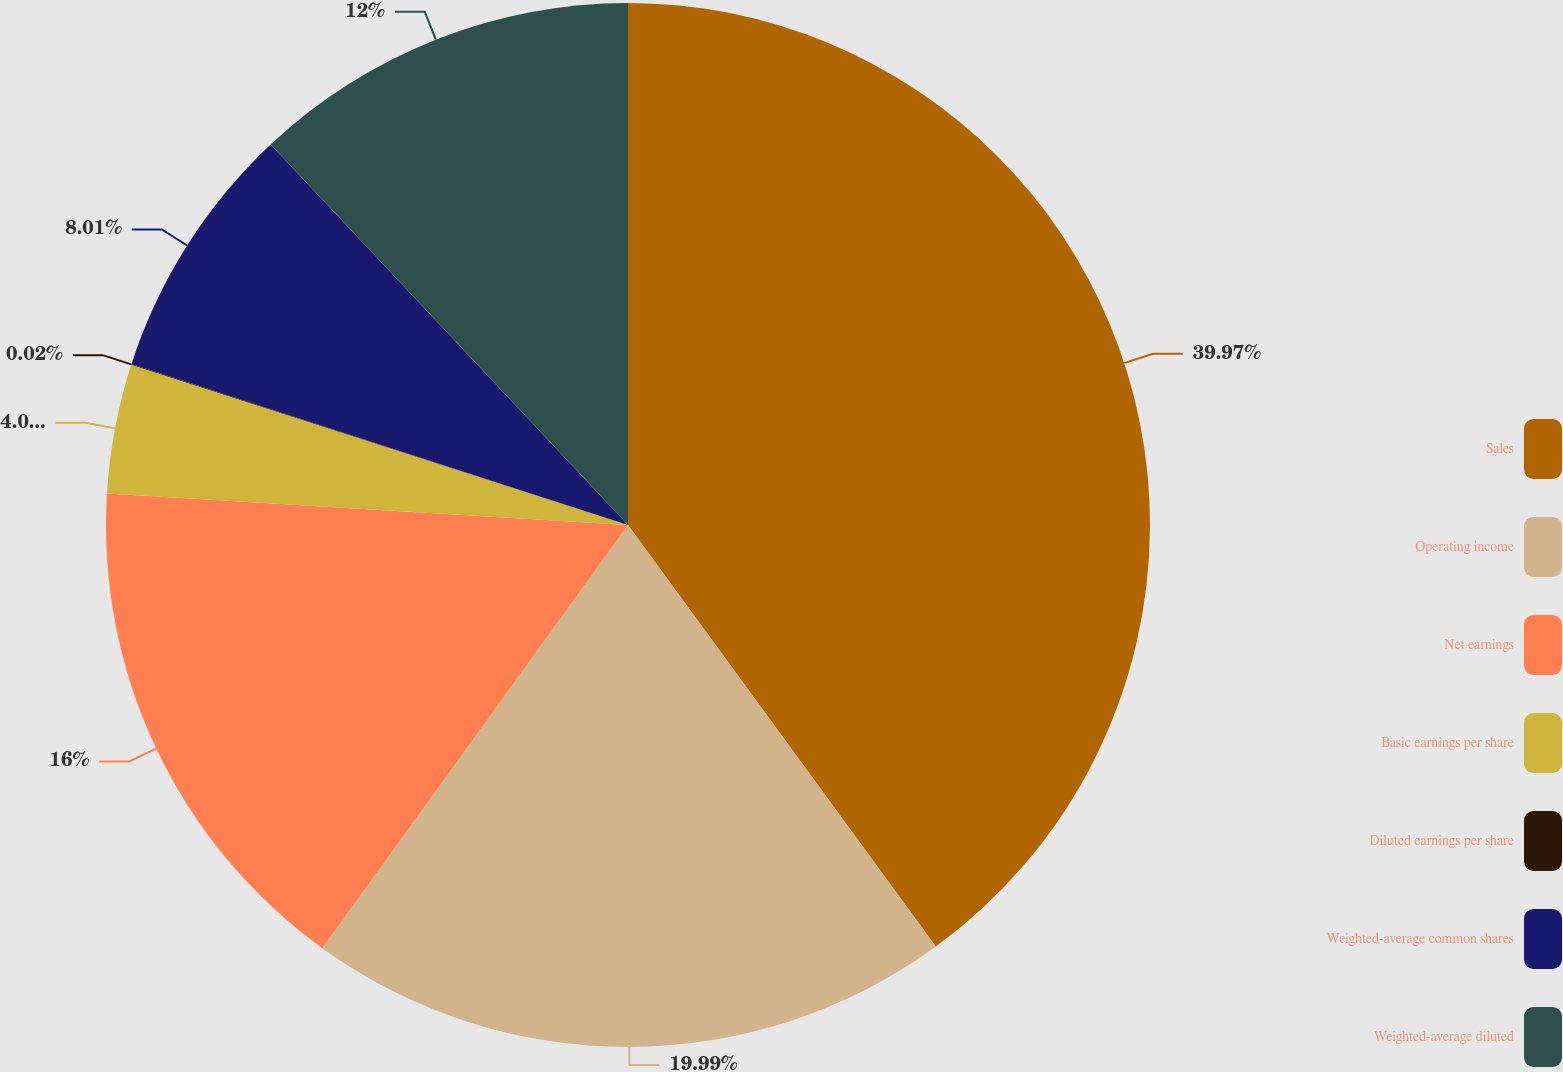Convert chart. <chart><loc_0><loc_0><loc_500><loc_500><pie_chart><fcel>Sales<fcel>Operating income<fcel>Net earnings<fcel>Basic earnings per share<fcel>Diluted earnings per share<fcel>Weighted-average common shares<fcel>Weighted-average diluted<nl><fcel>39.96%<fcel>19.99%<fcel>16.0%<fcel>4.01%<fcel>0.02%<fcel>8.01%<fcel>12.0%<nl></chart> 